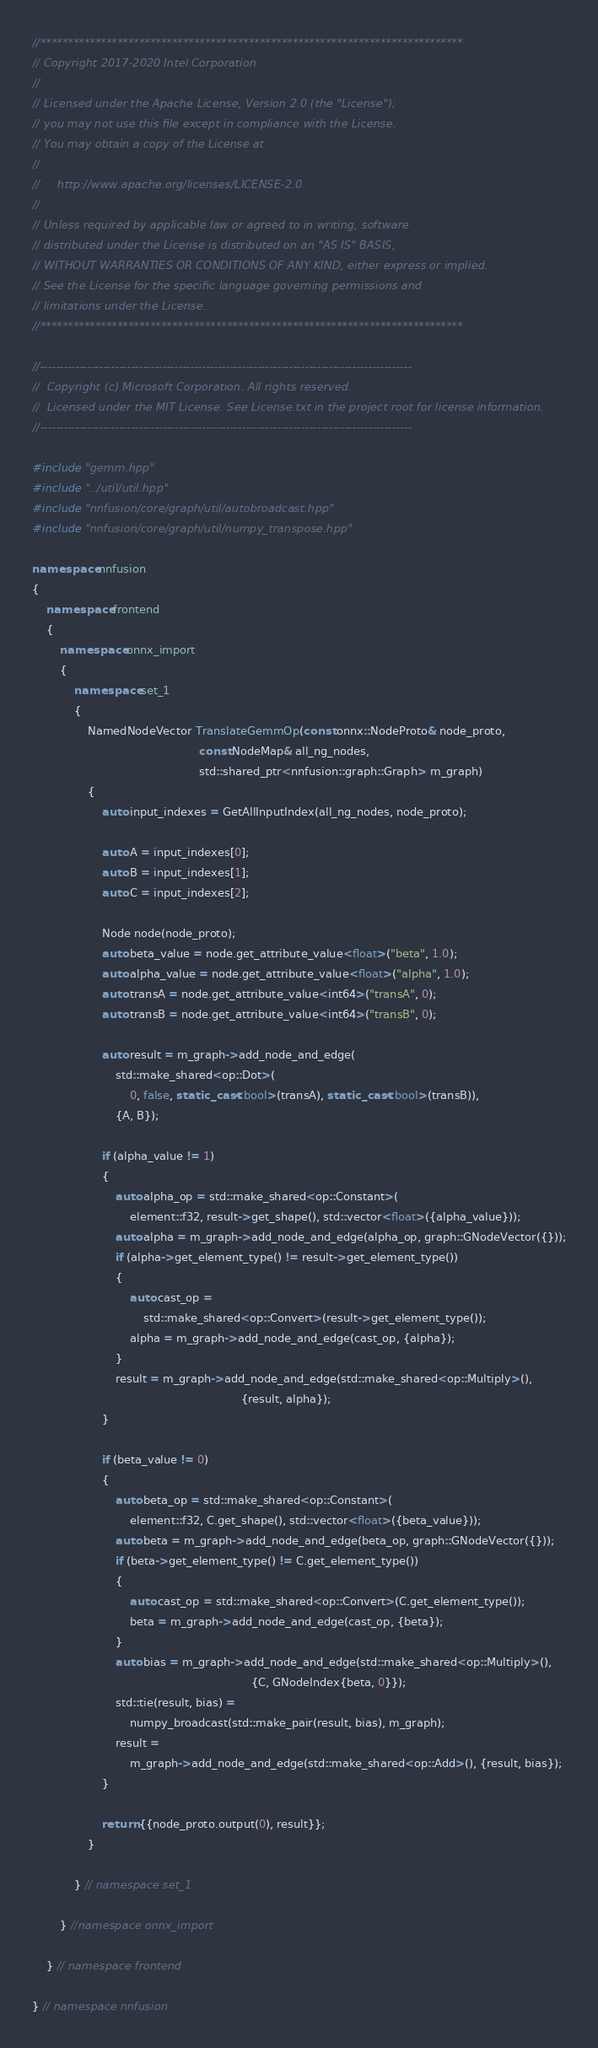Convert code to text. <code><loc_0><loc_0><loc_500><loc_500><_C++_>//*****************************************************************************
// Copyright 2017-2020 Intel Corporation
//
// Licensed under the Apache License, Version 2.0 (the "License");
// you may not use this file except in compliance with the License.
// You may obtain a copy of the License at
//
//     http://www.apache.org/licenses/LICENSE-2.0
//
// Unless required by applicable law or agreed to in writing, software
// distributed under the License is distributed on an "AS IS" BASIS,
// WITHOUT WARRANTIES OR CONDITIONS OF ANY KIND, either express or implied.
// See the License for the specific language governing permissions and
// limitations under the License.
//*****************************************************************************

//----------------------------------------------------------------------------------------------
//  Copyright (c) Microsoft Corporation. All rights reserved.
//  Licensed under the MIT License. See License.txt in the project root for license information.
//----------------------------------------------------------------------------------------------

#include "gemm.hpp"
#include "../util/util.hpp"
#include "nnfusion/core/graph/util/autobroadcast.hpp"
#include "nnfusion/core/graph/util/numpy_transpose.hpp"

namespace nnfusion
{
    namespace frontend
    {
        namespace onnx_import
        {
            namespace set_1
            {
                NamedNodeVector TranslateGemmOp(const onnx::NodeProto& node_proto,
                                                const NodeMap& all_ng_nodes,
                                                std::shared_ptr<nnfusion::graph::Graph> m_graph)
                {
                    auto input_indexes = GetAllInputIndex(all_ng_nodes, node_proto);

                    auto A = input_indexes[0];
                    auto B = input_indexes[1];
                    auto C = input_indexes[2];

                    Node node(node_proto);
                    auto beta_value = node.get_attribute_value<float>("beta", 1.0);
                    auto alpha_value = node.get_attribute_value<float>("alpha", 1.0);
                    auto transA = node.get_attribute_value<int64>("transA", 0);
                    auto transB = node.get_attribute_value<int64>("transB", 0);

                    auto result = m_graph->add_node_and_edge(
                        std::make_shared<op::Dot>(
                            0, false, static_cast<bool>(transA), static_cast<bool>(transB)),
                        {A, B});

                    if (alpha_value != 1)
                    {
                        auto alpha_op = std::make_shared<op::Constant>(
                            element::f32, result->get_shape(), std::vector<float>({alpha_value}));
                        auto alpha = m_graph->add_node_and_edge(alpha_op, graph::GNodeVector({}));
                        if (alpha->get_element_type() != result->get_element_type())
                        {
                            auto cast_op =
                                std::make_shared<op::Convert>(result->get_element_type());
                            alpha = m_graph->add_node_and_edge(cast_op, {alpha});
                        }
                        result = m_graph->add_node_and_edge(std::make_shared<op::Multiply>(),
                                                            {result, alpha});
                    }

                    if (beta_value != 0)
                    {
                        auto beta_op = std::make_shared<op::Constant>(
                            element::f32, C.get_shape(), std::vector<float>({beta_value}));
                        auto beta = m_graph->add_node_and_edge(beta_op, graph::GNodeVector({}));
                        if (beta->get_element_type() != C.get_element_type())
                        {
                            auto cast_op = std::make_shared<op::Convert>(C.get_element_type());
                            beta = m_graph->add_node_and_edge(cast_op, {beta});
                        }
                        auto bias = m_graph->add_node_and_edge(std::make_shared<op::Multiply>(),
                                                               {C, GNodeIndex{beta, 0}});
                        std::tie(result, bias) =
                            numpy_broadcast(std::make_pair(result, bias), m_graph);
                        result =
                            m_graph->add_node_and_edge(std::make_shared<op::Add>(), {result, bias});
                    }

                    return {{node_proto.output(0), result}};
                }

            } // namespace set_1

        } //namespace onnx_import

    } // namespace frontend

} // namespace nnfusion
</code> 